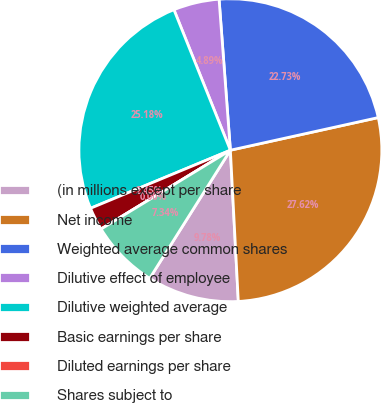<chart> <loc_0><loc_0><loc_500><loc_500><pie_chart><fcel>(in millions except per share<fcel>Net income<fcel>Weighted average common shares<fcel>Dilutive effect of employee<fcel>Dilutive weighted average<fcel>Basic earnings per share<fcel>Diluted earnings per share<fcel>Shares subject to<nl><fcel>9.78%<fcel>27.62%<fcel>22.73%<fcel>4.89%<fcel>25.18%<fcel>2.45%<fcel>0.0%<fcel>7.34%<nl></chart> 